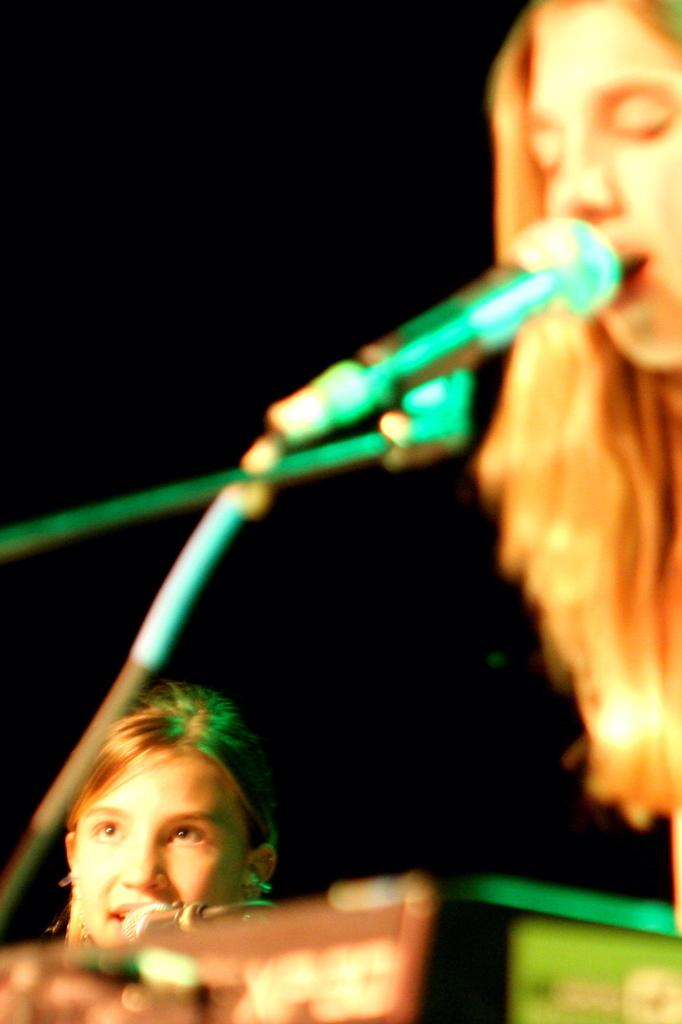How many people are in the image? There are two persons in the image. What is located in front of the persons? There is a mic in front of the persons. What might the persons be doing with the mic? The persons may be singing. What is the color of the background in the image? The background of the image is dark. What type of key is being used to play the music in the image? There is no key present in the image, and music is not being played through a key. 